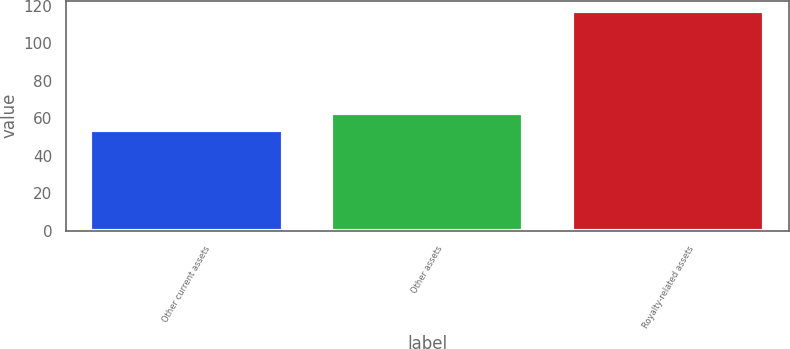Convert chart. <chart><loc_0><loc_0><loc_500><loc_500><bar_chart><fcel>Other current assets<fcel>Other assets<fcel>Royalty-related assets<nl><fcel>54<fcel>63<fcel>117<nl></chart> 